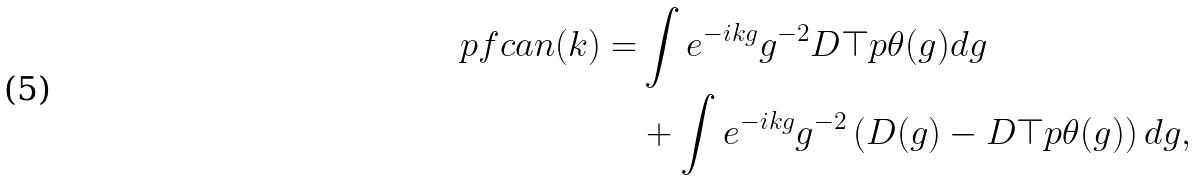Convert formula to latex. <formula><loc_0><loc_0><loc_500><loc_500>\ p f c a n ( k ) = & \int e ^ { - i k g } g ^ { - 2 } D \top p { \theta } ( g ) d g \\ & + \int e ^ { - i k g } g ^ { - 2 } \left ( D ( g ) - D \top p { \theta } ( g ) \right ) d g ,</formula> 